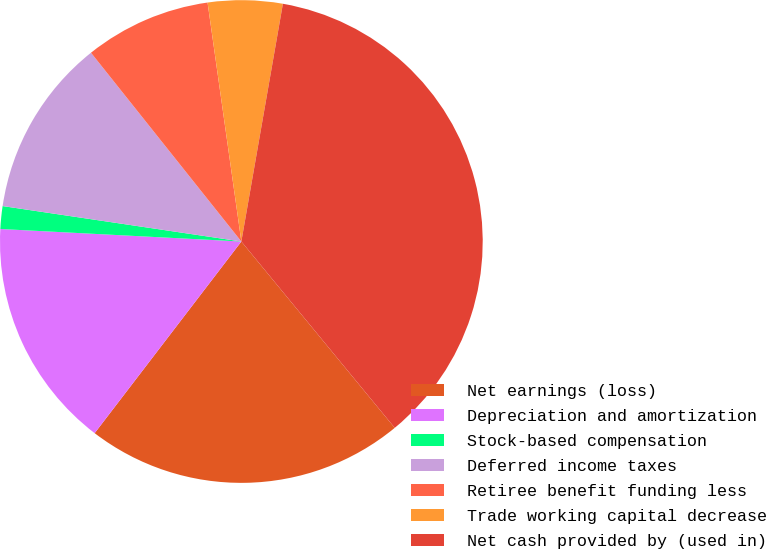Convert chart to OTSL. <chart><loc_0><loc_0><loc_500><loc_500><pie_chart><fcel>Net earnings (loss)<fcel>Depreciation and amortization<fcel>Stock-based compensation<fcel>Deferred income taxes<fcel>Retiree benefit funding less<fcel>Trade working capital decrease<fcel>Net cash provided by (used in)<nl><fcel>21.36%<fcel>15.43%<fcel>1.52%<fcel>11.95%<fcel>8.47%<fcel>4.99%<fcel>36.29%<nl></chart> 